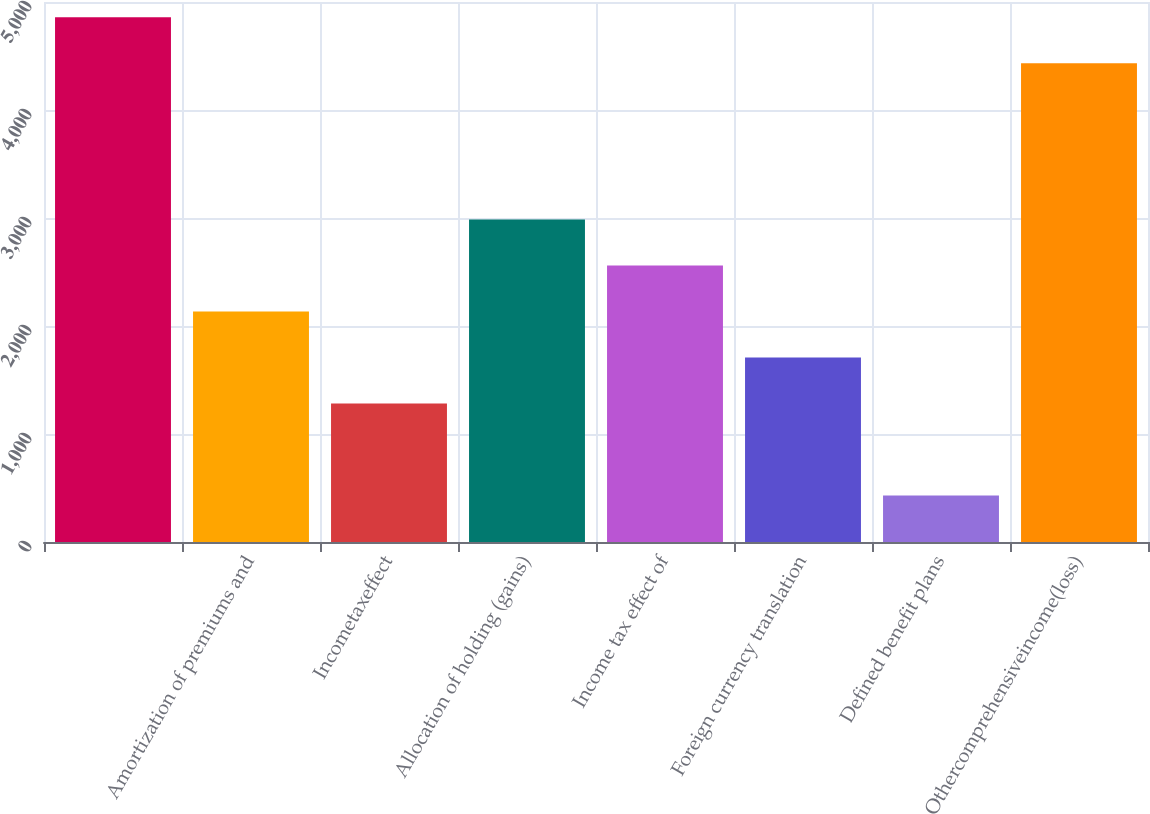Convert chart to OTSL. <chart><loc_0><loc_0><loc_500><loc_500><bar_chart><ecel><fcel>Amortization of premiums and<fcel>Incometaxeffect<fcel>Allocation of holding (gains)<fcel>Income tax effect of<fcel>Foreign currency translation<fcel>Defined benefit plans<fcel>Othercomprehensiveincome(loss)<nl><fcel>4858<fcel>2135<fcel>1283<fcel>2987<fcel>2561<fcel>1709<fcel>431<fcel>4432<nl></chart> 